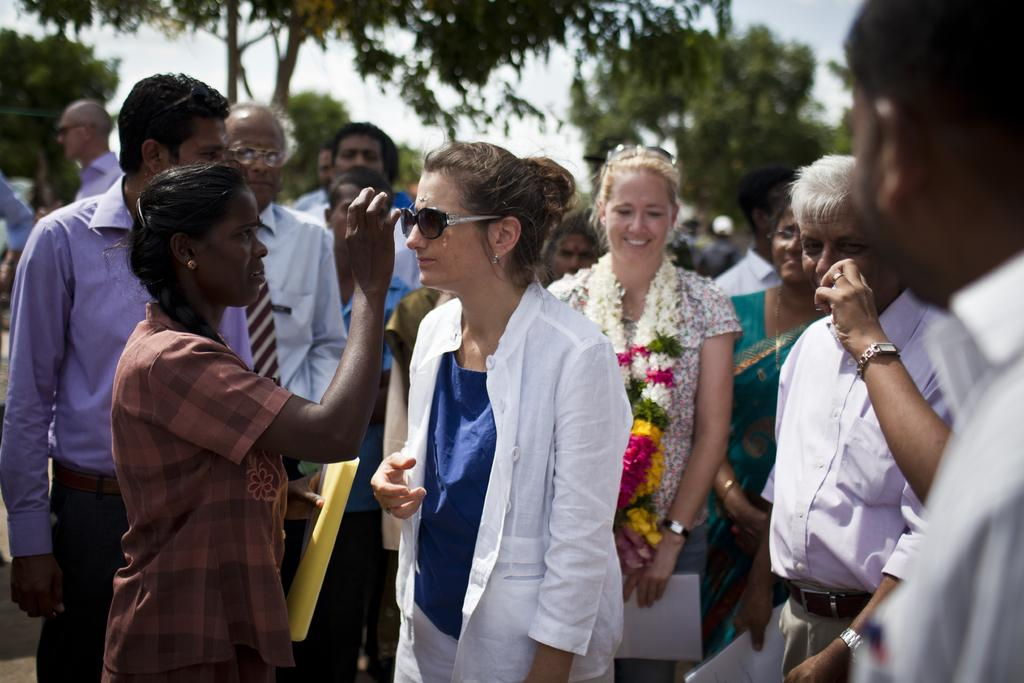How many people are in the image? There is a group of people in the image, but the exact number is not specified. What are some people doing in the image? Some people are holding objects in the image. What can be seen in the background of the image? There are trees and the sky visible in the background of the image. How many ducks are visible in the image? There are no ducks present in the image. What type of fire can be seen in the image? There is no fire present in the image. 